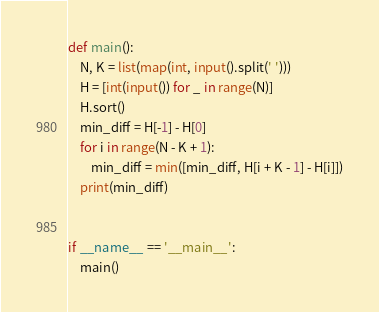Convert code to text. <code><loc_0><loc_0><loc_500><loc_500><_Python_>def main():
    N, K = list(map(int, input().split(' ')))
    H = [int(input()) for _ in range(N)]
    H.sort()
    min_diff = H[-1] - H[0]
    for i in range(N - K + 1):
        min_diff = min([min_diff, H[i + K - 1] - H[i]])
    print(min_diff)


if __name__ == '__main__':
    main()</code> 